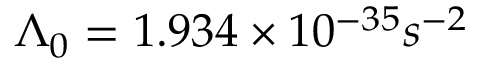<formula> <loc_0><loc_0><loc_500><loc_500>\Lambda _ { 0 } = 1 . 9 3 4 \times 1 0 ^ { - 3 5 } s ^ { - 2 }</formula> 